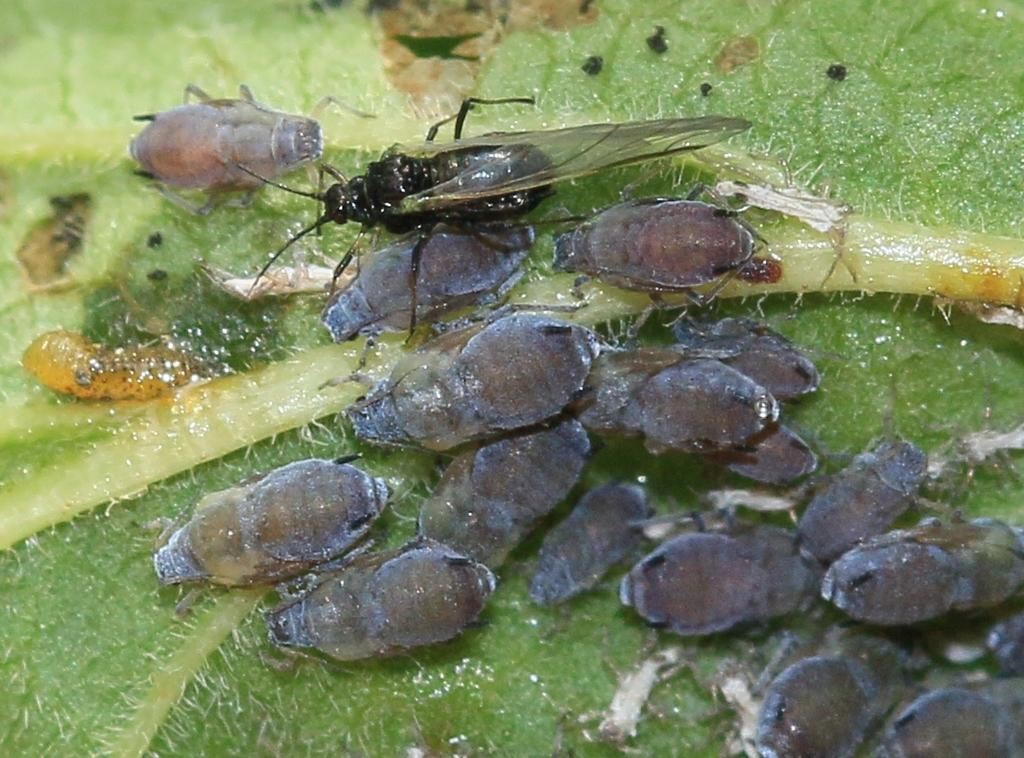What is the main subject of the image? The main subject of the image is insects on a leaf. Where are the insects located on the leaf? The insects are located in the middle of the leaf. What thought process can be observed in the insects in the image? There is no indication of any thought process in the image, as insects do not have the ability to think or have thoughts. 